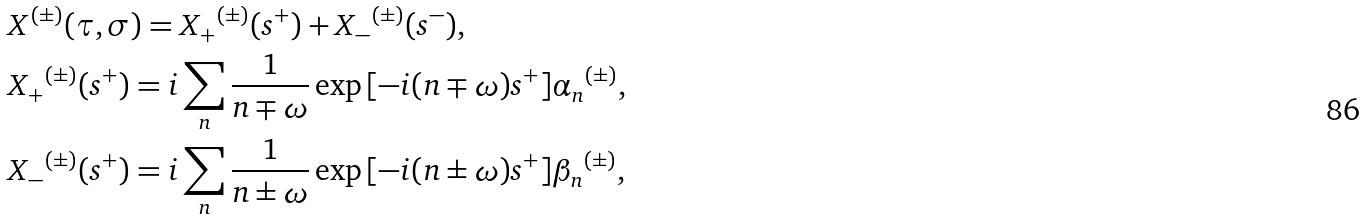Convert formula to latex. <formula><loc_0><loc_0><loc_500><loc_500>& X ^ { ( \pm ) } ( \tau , \sigma ) = { X _ { + } } ^ { ( \pm ) } ( s ^ { + } ) + { X _ { - } } ^ { ( \pm ) } ( s ^ { - } ) , \\ & { X _ { + } } ^ { ( \pm ) } ( s ^ { + } ) = i \sum _ { n } \frac { 1 } { n \mp \omega } \exp { [ - i ( n \mp \omega ) s ^ { + } ] } { \alpha _ { n } } ^ { ( \pm ) } , \\ & { X _ { - } } ^ { ( \pm ) } ( s ^ { + } ) = i \sum _ { n } \frac { 1 } { n \pm \omega } \exp { [ - i ( n \pm \omega ) s ^ { + } ] } { \beta _ { n } } ^ { ( \pm ) } ,</formula> 